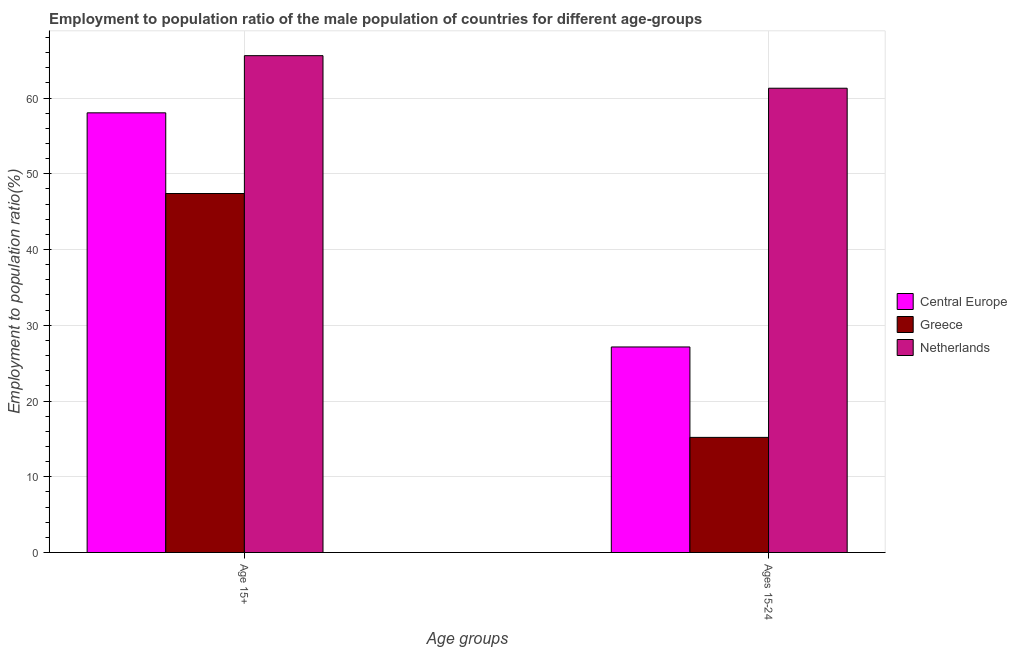How many different coloured bars are there?
Keep it short and to the point. 3. Are the number of bars per tick equal to the number of legend labels?
Your response must be concise. Yes. Are the number of bars on each tick of the X-axis equal?
Your answer should be compact. Yes. How many bars are there on the 2nd tick from the right?
Provide a succinct answer. 3. What is the label of the 1st group of bars from the left?
Provide a succinct answer. Age 15+. What is the employment to population ratio(age 15+) in Central Europe?
Provide a short and direct response. 58.05. Across all countries, what is the maximum employment to population ratio(age 15-24)?
Provide a short and direct response. 61.3. Across all countries, what is the minimum employment to population ratio(age 15-24)?
Provide a succinct answer. 15.2. In which country was the employment to population ratio(age 15+) maximum?
Your response must be concise. Netherlands. In which country was the employment to population ratio(age 15+) minimum?
Give a very brief answer. Greece. What is the total employment to population ratio(age 15-24) in the graph?
Your answer should be compact. 103.64. What is the difference between the employment to population ratio(age 15+) in Central Europe and that in Netherlands?
Your answer should be very brief. -7.55. What is the difference between the employment to population ratio(age 15+) in Central Europe and the employment to population ratio(age 15-24) in Greece?
Provide a short and direct response. 42.85. What is the average employment to population ratio(age 15+) per country?
Provide a short and direct response. 57.02. What is the difference between the employment to population ratio(age 15+) and employment to population ratio(age 15-24) in Netherlands?
Make the answer very short. 4.3. In how many countries, is the employment to population ratio(age 15+) greater than 14 %?
Provide a short and direct response. 3. What is the ratio of the employment to population ratio(age 15+) in Greece to that in Central Europe?
Keep it short and to the point. 0.82. Is the employment to population ratio(age 15-24) in Greece less than that in Central Europe?
Ensure brevity in your answer.  Yes. In how many countries, is the employment to population ratio(age 15-24) greater than the average employment to population ratio(age 15-24) taken over all countries?
Offer a terse response. 1. What does the 3rd bar from the right in Age 15+ represents?
Provide a short and direct response. Central Europe. How many bars are there?
Your answer should be compact. 6. What is the difference between two consecutive major ticks on the Y-axis?
Your answer should be compact. 10. Are the values on the major ticks of Y-axis written in scientific E-notation?
Provide a short and direct response. No. Does the graph contain any zero values?
Offer a terse response. No. Where does the legend appear in the graph?
Make the answer very short. Center right. What is the title of the graph?
Keep it short and to the point. Employment to population ratio of the male population of countries for different age-groups. What is the label or title of the X-axis?
Give a very brief answer. Age groups. What is the label or title of the Y-axis?
Offer a terse response. Employment to population ratio(%). What is the Employment to population ratio(%) in Central Europe in Age 15+?
Provide a succinct answer. 58.05. What is the Employment to population ratio(%) in Greece in Age 15+?
Make the answer very short. 47.4. What is the Employment to population ratio(%) of Netherlands in Age 15+?
Offer a very short reply. 65.6. What is the Employment to population ratio(%) in Central Europe in Ages 15-24?
Your answer should be very brief. 27.14. What is the Employment to population ratio(%) of Greece in Ages 15-24?
Offer a terse response. 15.2. What is the Employment to population ratio(%) in Netherlands in Ages 15-24?
Offer a terse response. 61.3. Across all Age groups, what is the maximum Employment to population ratio(%) in Central Europe?
Make the answer very short. 58.05. Across all Age groups, what is the maximum Employment to population ratio(%) in Greece?
Keep it short and to the point. 47.4. Across all Age groups, what is the maximum Employment to population ratio(%) of Netherlands?
Ensure brevity in your answer.  65.6. Across all Age groups, what is the minimum Employment to population ratio(%) of Central Europe?
Your answer should be very brief. 27.14. Across all Age groups, what is the minimum Employment to population ratio(%) in Greece?
Your answer should be very brief. 15.2. Across all Age groups, what is the minimum Employment to population ratio(%) of Netherlands?
Provide a succinct answer. 61.3. What is the total Employment to population ratio(%) of Central Europe in the graph?
Provide a short and direct response. 85.19. What is the total Employment to population ratio(%) in Greece in the graph?
Your answer should be very brief. 62.6. What is the total Employment to population ratio(%) in Netherlands in the graph?
Your response must be concise. 126.9. What is the difference between the Employment to population ratio(%) of Central Europe in Age 15+ and that in Ages 15-24?
Ensure brevity in your answer.  30.91. What is the difference between the Employment to population ratio(%) in Greece in Age 15+ and that in Ages 15-24?
Give a very brief answer. 32.2. What is the difference between the Employment to population ratio(%) of Netherlands in Age 15+ and that in Ages 15-24?
Offer a terse response. 4.3. What is the difference between the Employment to population ratio(%) in Central Europe in Age 15+ and the Employment to population ratio(%) in Greece in Ages 15-24?
Offer a very short reply. 42.85. What is the difference between the Employment to population ratio(%) in Central Europe in Age 15+ and the Employment to population ratio(%) in Netherlands in Ages 15-24?
Your response must be concise. -3.25. What is the difference between the Employment to population ratio(%) of Greece in Age 15+ and the Employment to population ratio(%) of Netherlands in Ages 15-24?
Offer a very short reply. -13.9. What is the average Employment to population ratio(%) of Central Europe per Age groups?
Your answer should be very brief. 42.59. What is the average Employment to population ratio(%) of Greece per Age groups?
Offer a terse response. 31.3. What is the average Employment to population ratio(%) of Netherlands per Age groups?
Keep it short and to the point. 63.45. What is the difference between the Employment to population ratio(%) of Central Europe and Employment to population ratio(%) of Greece in Age 15+?
Offer a very short reply. 10.65. What is the difference between the Employment to population ratio(%) in Central Europe and Employment to population ratio(%) in Netherlands in Age 15+?
Ensure brevity in your answer.  -7.55. What is the difference between the Employment to population ratio(%) of Greece and Employment to population ratio(%) of Netherlands in Age 15+?
Your response must be concise. -18.2. What is the difference between the Employment to population ratio(%) of Central Europe and Employment to population ratio(%) of Greece in Ages 15-24?
Provide a short and direct response. 11.94. What is the difference between the Employment to population ratio(%) of Central Europe and Employment to population ratio(%) of Netherlands in Ages 15-24?
Keep it short and to the point. -34.16. What is the difference between the Employment to population ratio(%) in Greece and Employment to population ratio(%) in Netherlands in Ages 15-24?
Your answer should be compact. -46.1. What is the ratio of the Employment to population ratio(%) in Central Europe in Age 15+ to that in Ages 15-24?
Your response must be concise. 2.14. What is the ratio of the Employment to population ratio(%) in Greece in Age 15+ to that in Ages 15-24?
Keep it short and to the point. 3.12. What is the ratio of the Employment to population ratio(%) of Netherlands in Age 15+ to that in Ages 15-24?
Provide a short and direct response. 1.07. What is the difference between the highest and the second highest Employment to population ratio(%) of Central Europe?
Your response must be concise. 30.91. What is the difference between the highest and the second highest Employment to population ratio(%) in Greece?
Offer a very short reply. 32.2. What is the difference between the highest and the second highest Employment to population ratio(%) in Netherlands?
Your response must be concise. 4.3. What is the difference between the highest and the lowest Employment to population ratio(%) of Central Europe?
Your answer should be compact. 30.91. What is the difference between the highest and the lowest Employment to population ratio(%) in Greece?
Provide a succinct answer. 32.2. What is the difference between the highest and the lowest Employment to population ratio(%) of Netherlands?
Give a very brief answer. 4.3. 